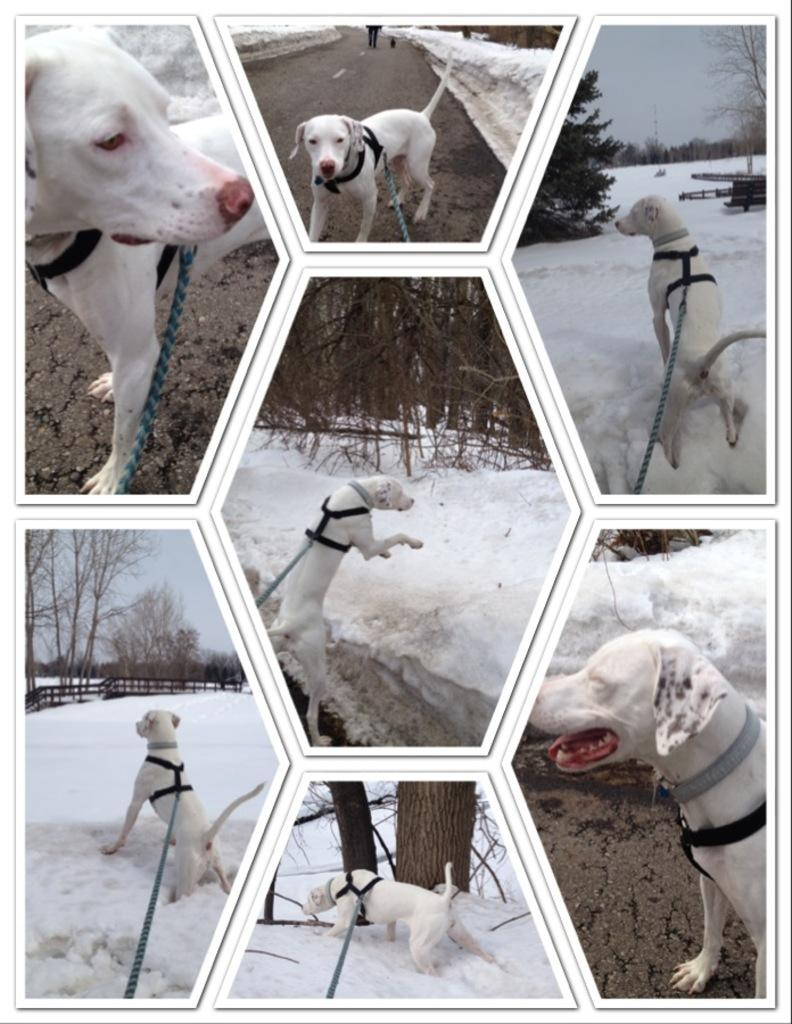What is the main subject of the image? The main subject of the image is a collage of pictures. Can you describe one of the pictures in the collage? The collage contains a picture of a dog on the ground. What type of natural elements can be seen in the collage? There are trees visible in the collage. What architectural feature is present in the collage? There is a fence in the collage. What is visible in the background of the collage? The sky is visible in the background of the collage. How does the zephyr affect the dog's tail in the image? There is no mention of a zephyr or a dog's tail in the image; it only contains a collage of pictures. 